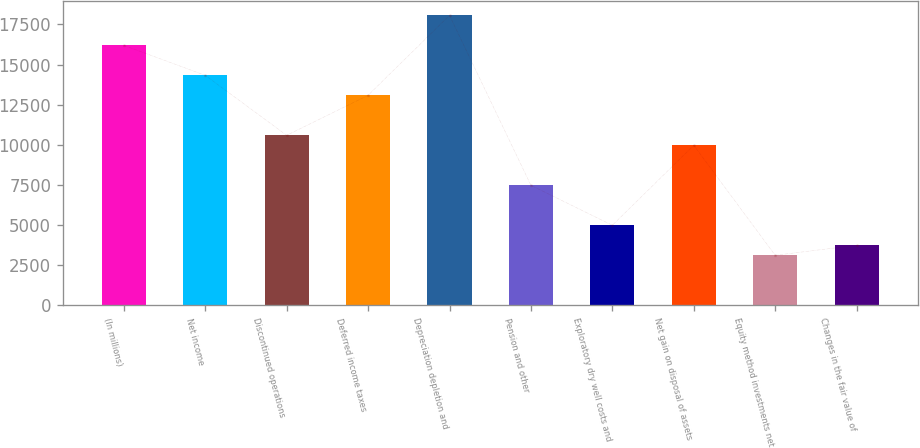Convert chart to OTSL. <chart><loc_0><loc_0><loc_500><loc_500><bar_chart><fcel>(In millions)<fcel>Net income<fcel>Discontinued operations<fcel>Deferred income taxes<fcel>Depreciation depletion and<fcel>Pension and other<fcel>Exploratory dry well costs and<fcel>Net gain on disposal of assets<fcel>Equity method investments net<fcel>Changes in the fair value of<nl><fcel>16194.2<fcel>14326.1<fcel>10589.9<fcel>13080.7<fcel>18062.3<fcel>7476.4<fcel>4985.6<fcel>9967.2<fcel>3117.5<fcel>3740.2<nl></chart> 